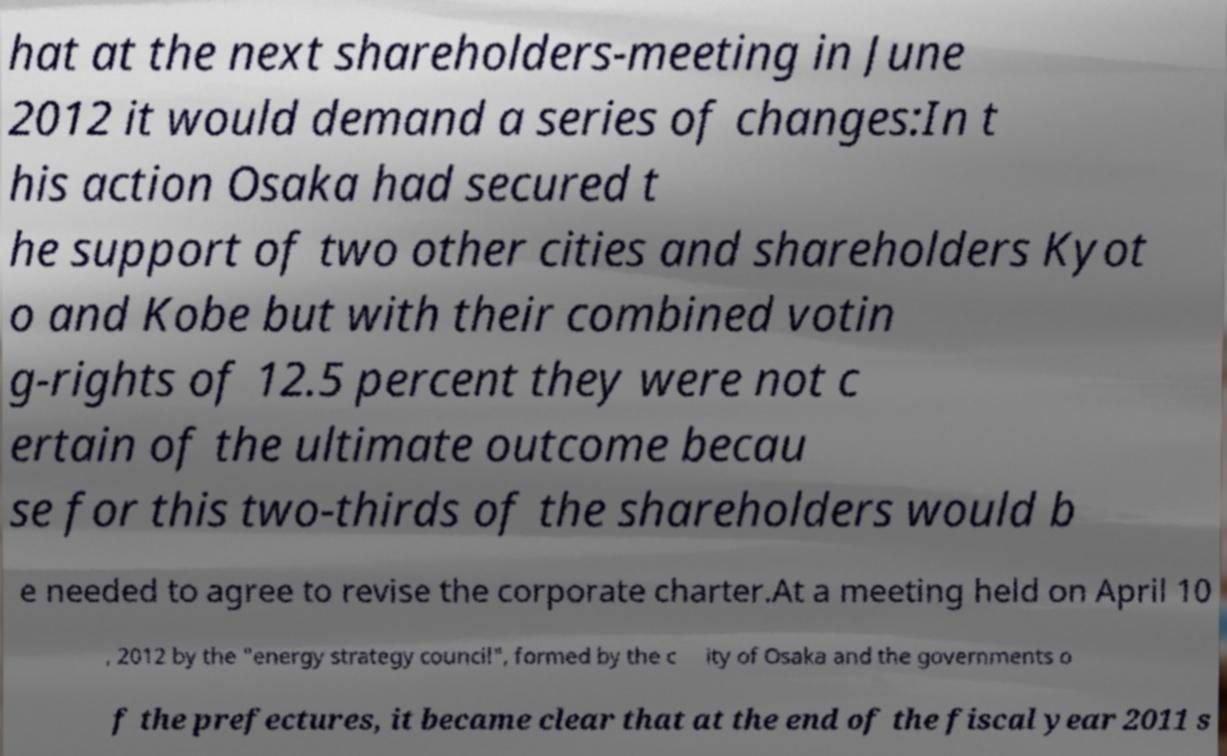Can you read and provide the text displayed in the image?This photo seems to have some interesting text. Can you extract and type it out for me? hat at the next shareholders-meeting in June 2012 it would demand a series of changes:In t his action Osaka had secured t he support of two other cities and shareholders Kyot o and Kobe but with their combined votin g-rights of 12.5 percent they were not c ertain of the ultimate outcome becau se for this two-thirds of the shareholders would b e needed to agree to revise the corporate charter.At a meeting held on April 10 , 2012 by the "energy strategy council", formed by the c ity of Osaka and the governments o f the prefectures, it became clear that at the end of the fiscal year 2011 s 